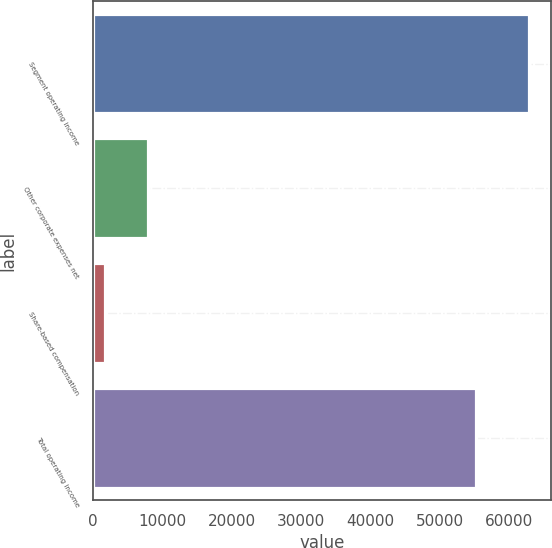<chart> <loc_0><loc_0><loc_500><loc_500><bar_chart><fcel>Segment operating income<fcel>Other corporate expenses net<fcel>Share-based compensation<fcel>Total operating income<nl><fcel>62853<fcel>7851.3<fcel>1740<fcel>55241<nl></chart> 